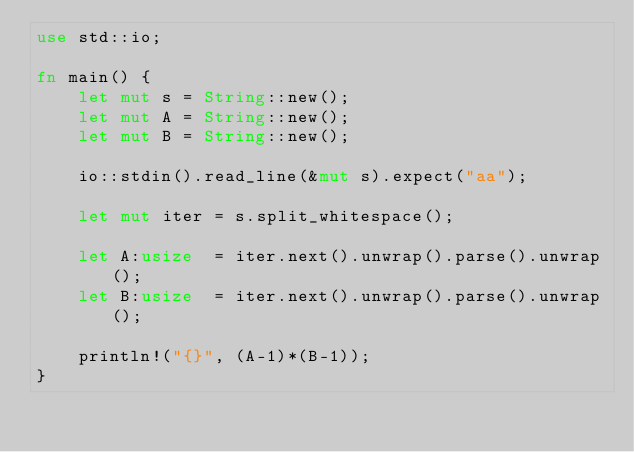Convert code to text. <code><loc_0><loc_0><loc_500><loc_500><_Rust_>use std::io;

fn main() {
    let mut s = String::new();
    let mut A = String::new();
    let mut B = String::new();

    io::stdin().read_line(&mut s).expect("aa");

    let mut iter = s.split_whitespace();

    let A:usize  = iter.next().unwrap().parse().unwrap();
    let B:usize  = iter.next().unwrap().parse().unwrap();

    println!("{}", (A-1)*(B-1));
}</code> 